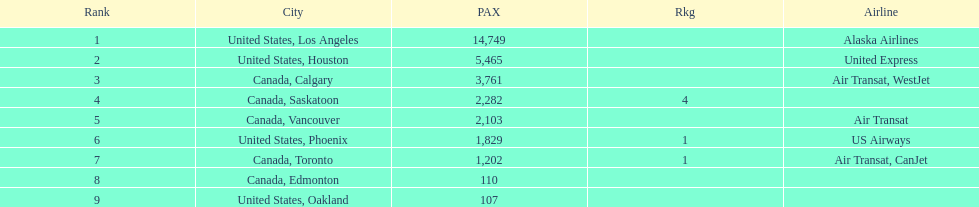Which airline carries the most passengers? Alaska Airlines. 